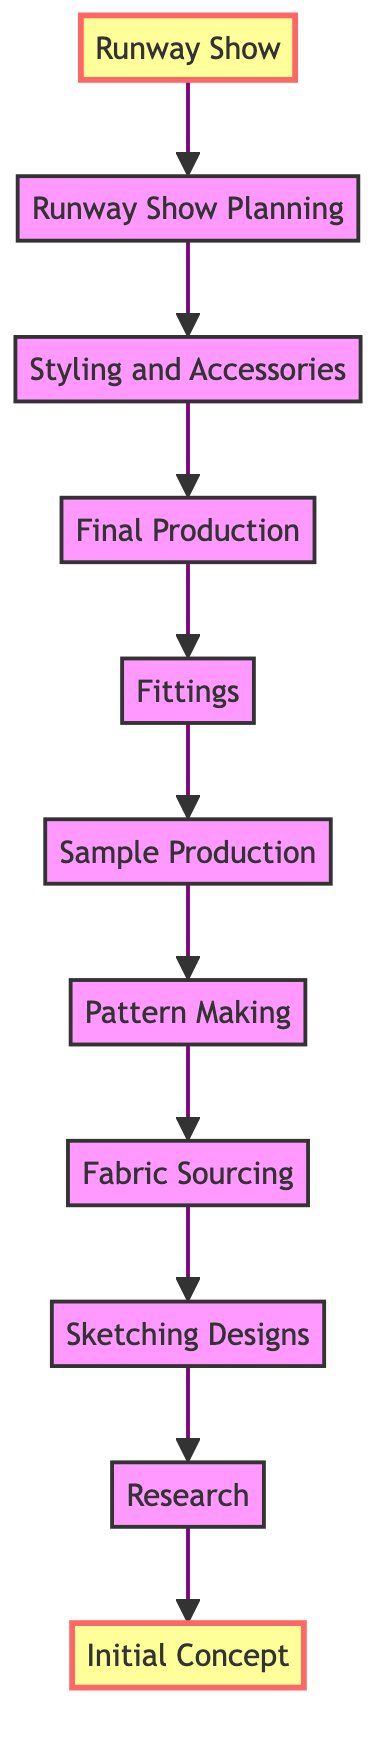What is the first step in the timeline? The first step in the flow chart is labeled "Initial Concept." This can be found at the bottom of the diagram and is the starting point of the flow.
Answer: Initial Concept How many steps are there in total? By counting each distinct node in the diagram, we find that there are a total of 11 steps represented from the bottom to the top.
Answer: 11 What step comes immediately after Fabric Sourcing? By following the arrows upward from "Fabric Sourcing," we see that the next step is "Pattern Making." This is the direct connection indicated in the flow.
Answer: Pattern Making Which step has the highest position in the diagram? The highest position in a bottom-to-top flow chart typically indicates the final outcome or event. In this case, "Runway Show" is the highest step in the diagram.
Answer: Runway Show What happens after Fittings? Taking the flow from "Fittings," the next step in line is "Final Production." This follows the upward direction established in the diagram.
Answer: Final Production What is the relationship between Sketching Designs and Initial Concept? "Sketching Designs" is positioned directly above "Research," which in turn is above the "Initial Concept." Therefore, "Sketching Designs" comes after "Initial Concept," indicating a flow of development.
Answer: Sketching Designs follows Initial Concept Which two steps are connected directly to Styling and Accessories? Analyzing the diagram, "Styling and Accessories" connects directly to both "Runway Show Planning" above it and "Final Production" below it. This shows its placement between two different stages.
Answer: Final Production, Runway Show Planning How does the diagram indicate progression from concept to runway? The diagram uses arrows to show an upward flow, guiding the viewer from "Initial Concept" at the bottom to "Runway Show" at the top, illustrating the timeline of development clearly.
Answer: Through upward arrows 